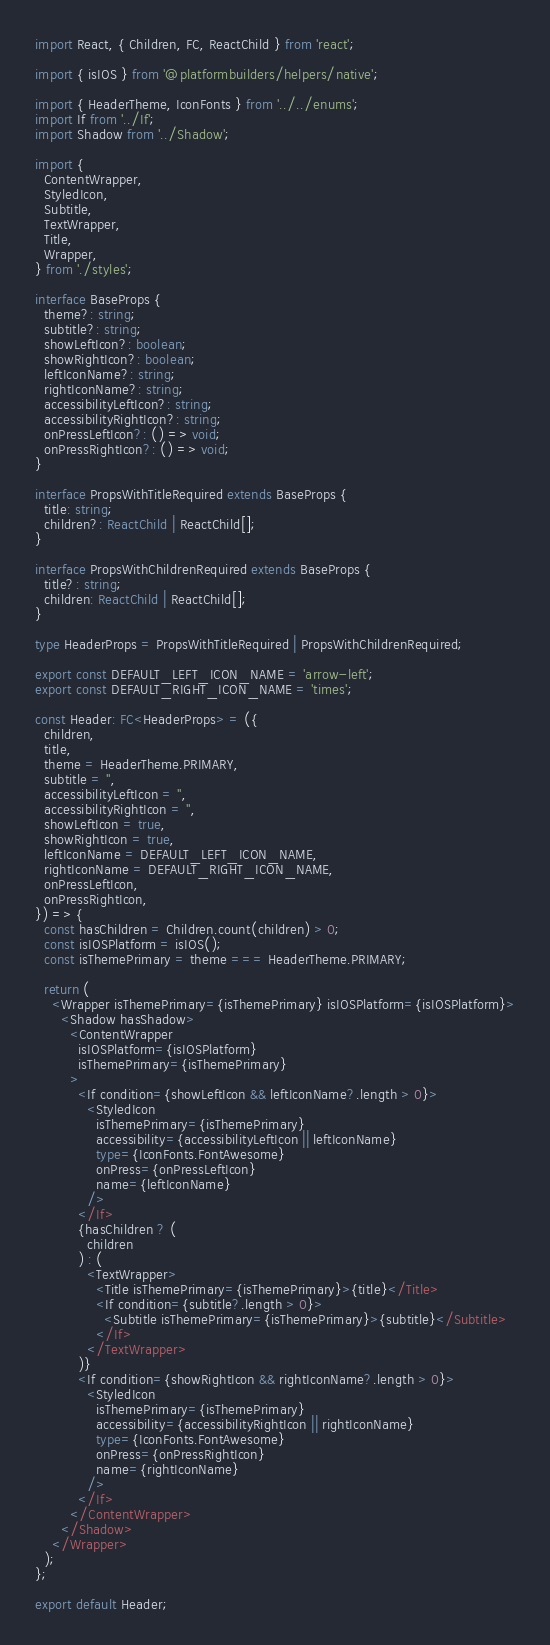Convert code to text. <code><loc_0><loc_0><loc_500><loc_500><_TypeScript_>import React, { Children, FC, ReactChild } from 'react';

import { isIOS } from '@platformbuilders/helpers/native';

import { HeaderTheme, IconFonts } from '../../enums';
import If from '../If';
import Shadow from '../Shadow';

import {
  ContentWrapper,
  StyledIcon,
  Subtitle,
  TextWrapper,
  Title,
  Wrapper,
} from './styles';

interface BaseProps {
  theme?: string;
  subtitle?: string;
  showLeftIcon?: boolean;
  showRightIcon?: boolean;
  leftIconName?: string;
  rightIconName?: string;
  accessibilityLeftIcon?: string;
  accessibilityRightIcon?: string;
  onPressLeftIcon?: () => void;
  onPressRightIcon?: () => void;
}

interface PropsWithTitleRequired extends BaseProps {
  title: string;
  children?: ReactChild | ReactChild[];
}

interface PropsWithChildrenRequired extends BaseProps {
  title?: string;
  children: ReactChild | ReactChild[];
}

type HeaderProps = PropsWithTitleRequired | PropsWithChildrenRequired;

export const DEFAULT_LEFT_ICON_NAME = 'arrow-left';
export const DEFAULT_RIGHT_ICON_NAME = 'times';

const Header: FC<HeaderProps> = ({
  children,
  title,
  theme = HeaderTheme.PRIMARY,
  subtitle = '',
  accessibilityLeftIcon = '',
  accessibilityRightIcon = '',
  showLeftIcon = true,
  showRightIcon = true,
  leftIconName = DEFAULT_LEFT_ICON_NAME,
  rightIconName = DEFAULT_RIGHT_ICON_NAME,
  onPressLeftIcon,
  onPressRightIcon,
}) => {
  const hasChildren = Children.count(children) > 0;
  const isIOSPlatform = isIOS();
  const isThemePrimary = theme === HeaderTheme.PRIMARY;

  return (
    <Wrapper isThemePrimary={isThemePrimary} isIOSPlatform={isIOSPlatform}>
      <Shadow hasShadow>
        <ContentWrapper
          isIOSPlatform={isIOSPlatform}
          isThemePrimary={isThemePrimary}
        >
          <If condition={showLeftIcon && leftIconName?.length > 0}>
            <StyledIcon
              isThemePrimary={isThemePrimary}
              accessibility={accessibilityLeftIcon || leftIconName}
              type={IconFonts.FontAwesome}
              onPress={onPressLeftIcon}
              name={leftIconName}
            />
          </If>
          {hasChildren ? (
            children
          ) : (
            <TextWrapper>
              <Title isThemePrimary={isThemePrimary}>{title}</Title>
              <If condition={subtitle?.length > 0}>
                <Subtitle isThemePrimary={isThemePrimary}>{subtitle}</Subtitle>
              </If>
            </TextWrapper>
          )}
          <If condition={showRightIcon && rightIconName?.length > 0}>
            <StyledIcon
              isThemePrimary={isThemePrimary}
              accessibility={accessibilityRightIcon || rightIconName}
              type={IconFonts.FontAwesome}
              onPress={onPressRightIcon}
              name={rightIconName}
            />
          </If>
        </ContentWrapper>
      </Shadow>
    </Wrapper>
  );
};

export default Header;
</code> 